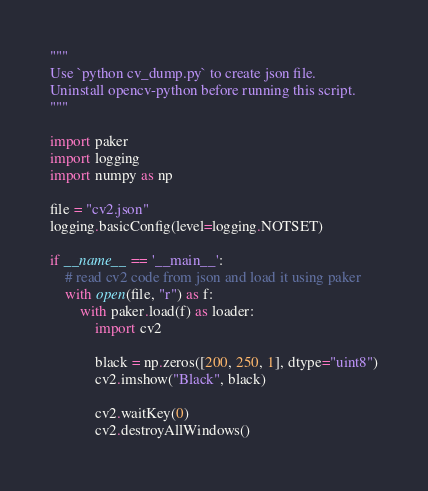<code> <loc_0><loc_0><loc_500><loc_500><_Python_>"""
Use `python cv_dump.py` to create json file.
Uninstall opencv-python before running this script.
"""

import paker
import logging
import numpy as np

file = "cv2.json"
logging.basicConfig(level=logging.NOTSET)

if __name__ == '__main__':
    # read cv2 code from json and load it using paker
    with open(file, "r") as f:
        with paker.load(f) as loader:
            import cv2

            black = np.zeros([200, 250, 1], dtype="uint8")
            cv2.imshow("Black", black)

            cv2.waitKey(0)
            cv2.destroyAllWindows()
</code> 